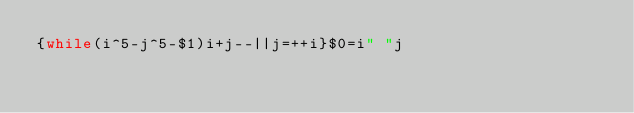<code> <loc_0><loc_0><loc_500><loc_500><_Awk_>{while(i^5-j^5-$1)i+j--||j=++i}$0=i" "j</code> 